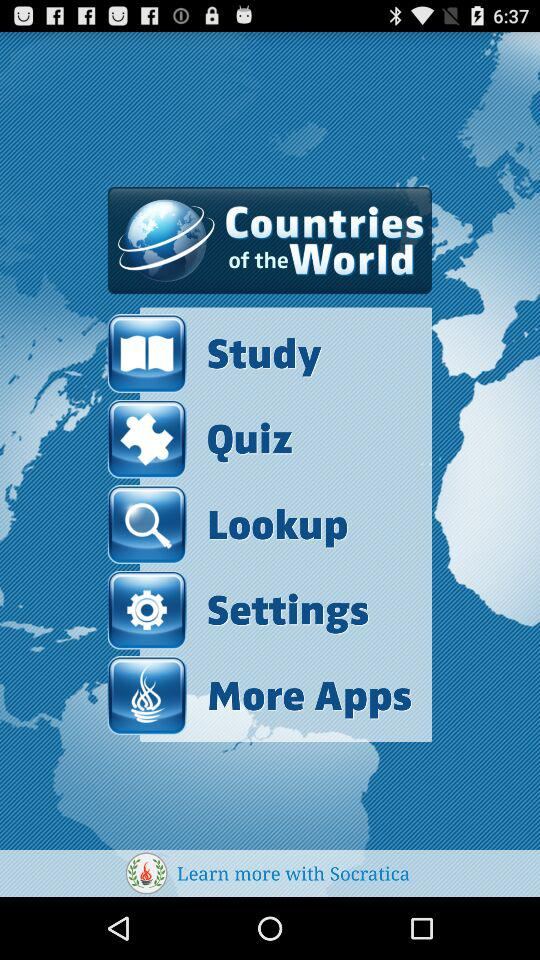Which menu item is selected?
When the provided information is insufficient, respond with <no answer>. <no answer> 